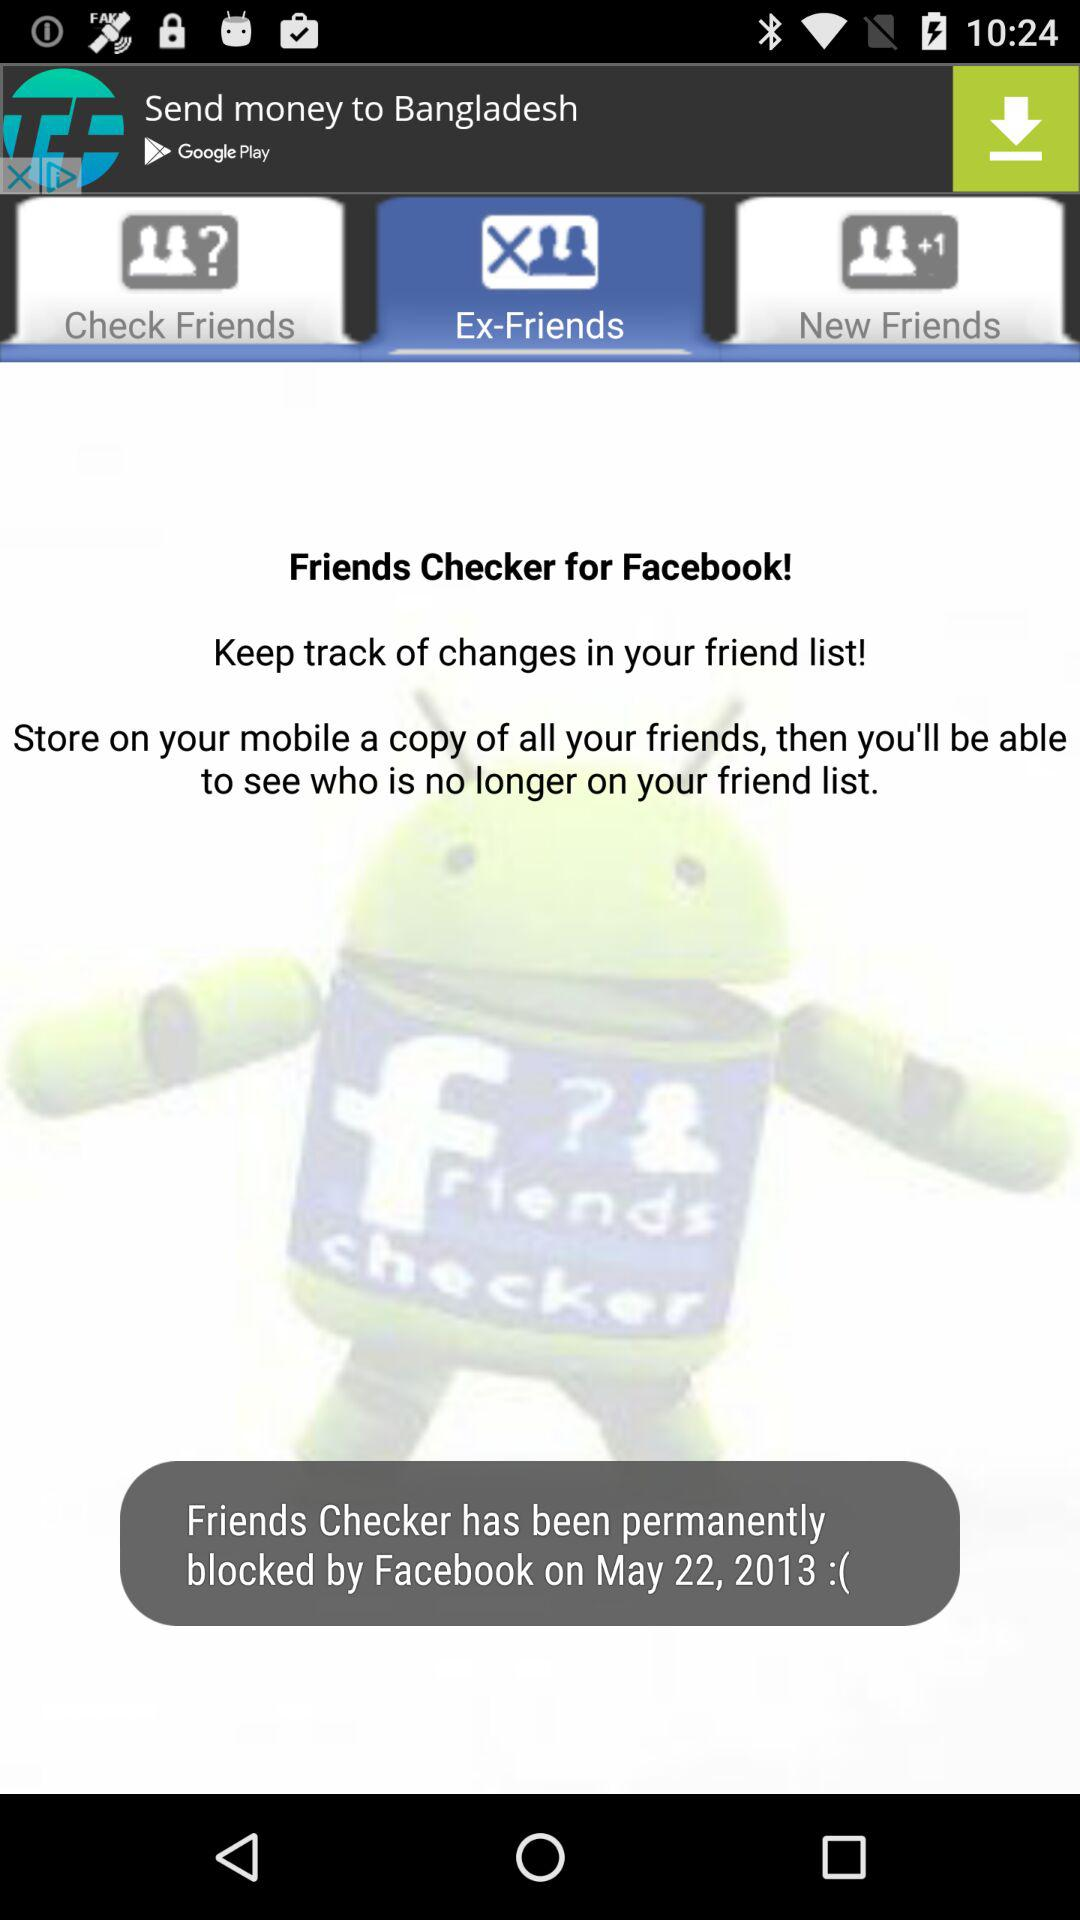When was Friends Checker blocked by Facebook? The Friends Checker was blocked by Facebook on May 22, 2013. 